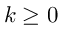Convert formula to latex. <formula><loc_0><loc_0><loc_500><loc_500>k \geq 0</formula> 